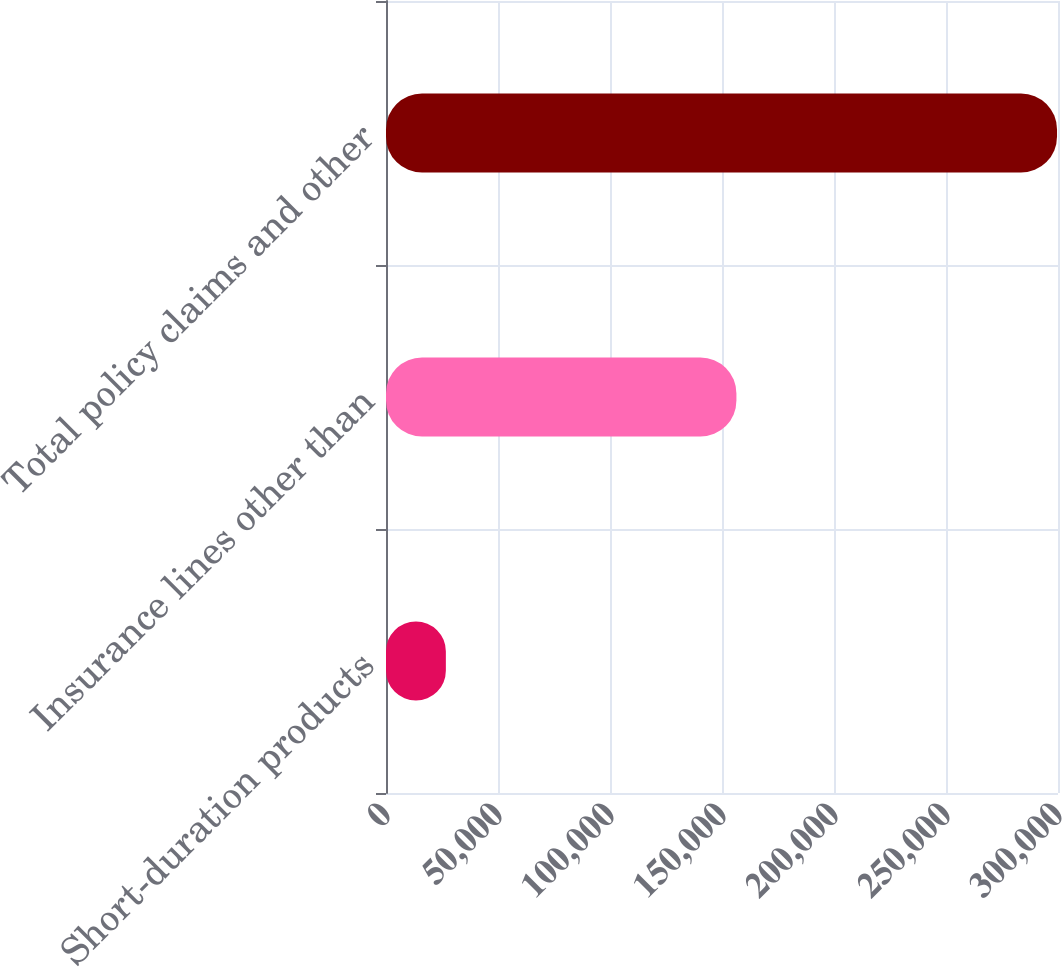<chart> <loc_0><loc_0><loc_500><loc_500><bar_chart><fcel>Short-duration products<fcel>Insurance lines other than<fcel>Total policy claims and other<nl><fcel>26721<fcel>156437<fcel>299565<nl></chart> 